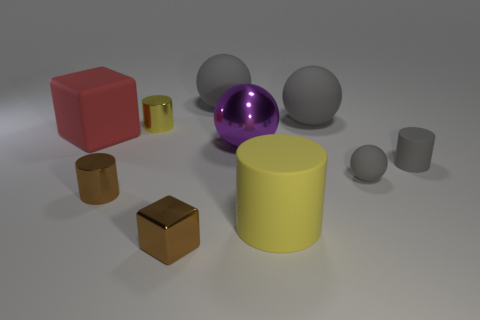Is the number of tiny gray rubber balls in front of the big yellow matte cylinder less than the number of gray rubber things that are behind the large red thing?
Offer a very short reply. Yes. Do the tiny yellow shiny thing and the yellow rubber object have the same shape?
Make the answer very short. Yes. How many other objects are the same size as the brown metal cube?
Give a very brief answer. 4. What number of things are metal cylinders that are behind the metallic cube or metallic things behind the big yellow matte cylinder?
Your answer should be compact. 3. What number of other tiny things have the same shape as the yellow shiny object?
Keep it short and to the point. 2. There is a cylinder that is both right of the big metallic object and left of the gray cylinder; what is it made of?
Your answer should be compact. Rubber. There is a purple metallic thing; how many gray cylinders are right of it?
Make the answer very short. 1. What number of tiny gray things are there?
Offer a very short reply. 2. Do the brown cylinder and the red matte object have the same size?
Keep it short and to the point. No. Is there a cylinder that is left of the yellow object behind the tiny gray object left of the tiny gray cylinder?
Keep it short and to the point. Yes. 